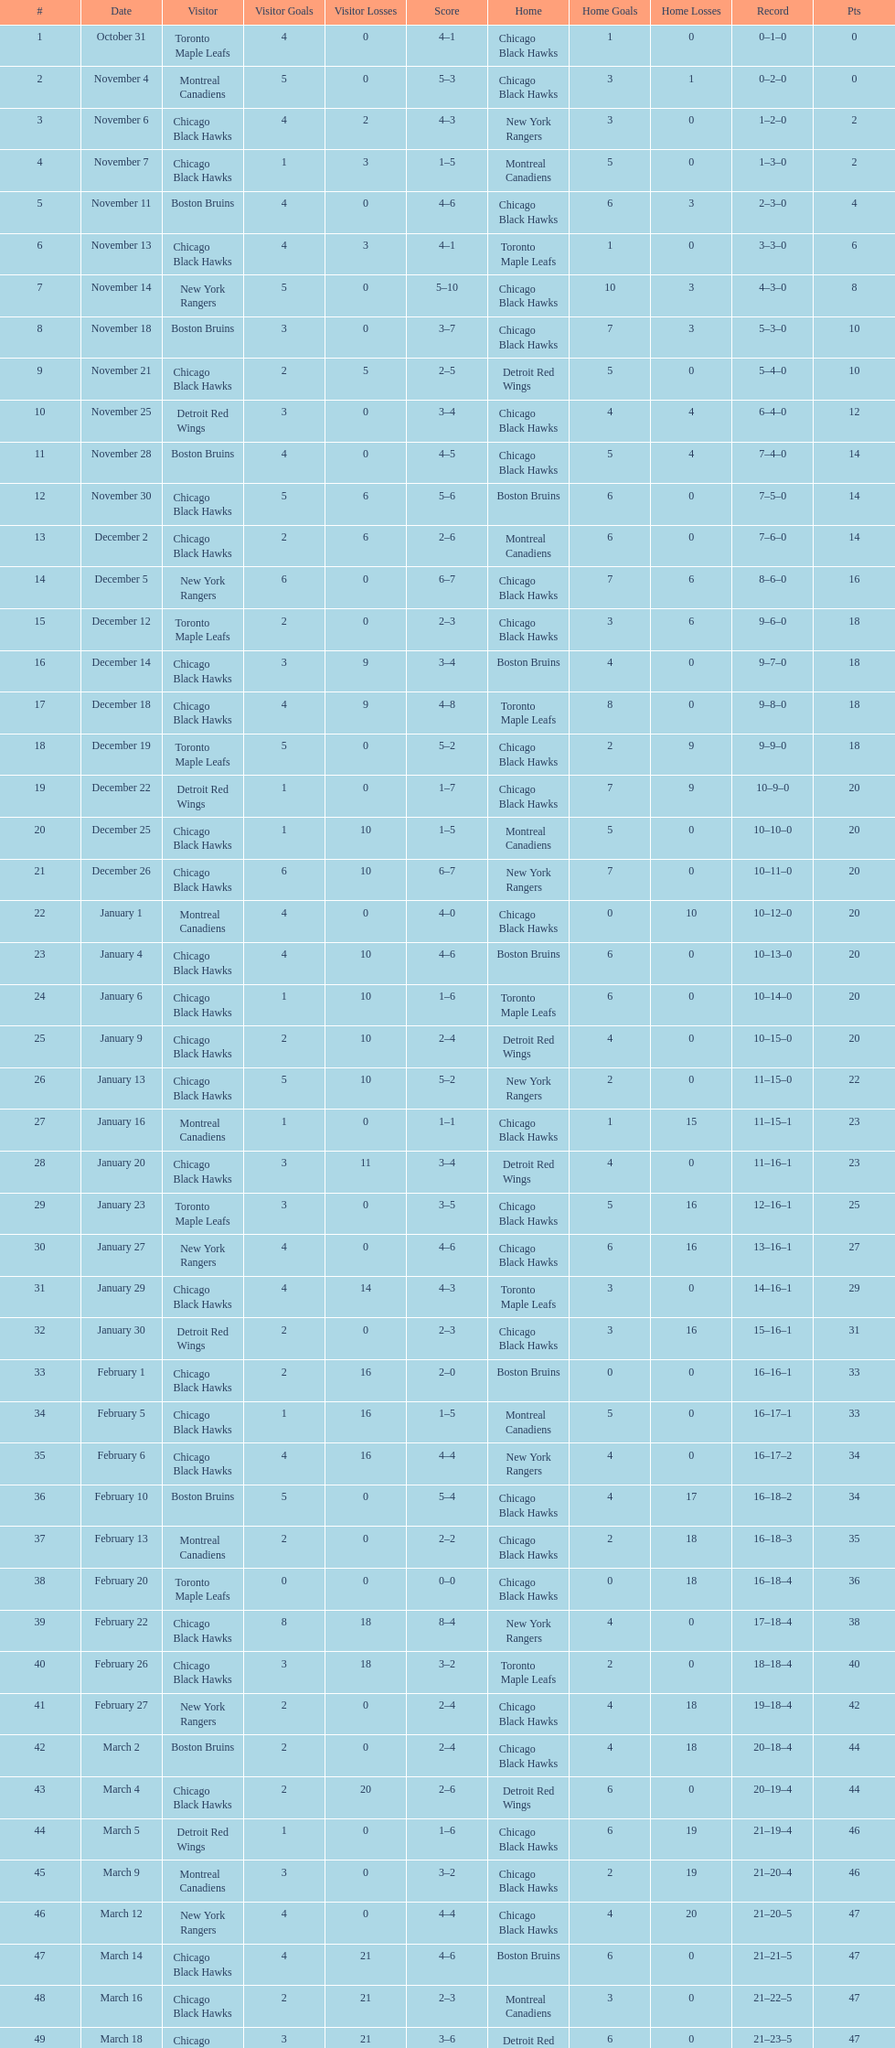How many games total were played? 50. 